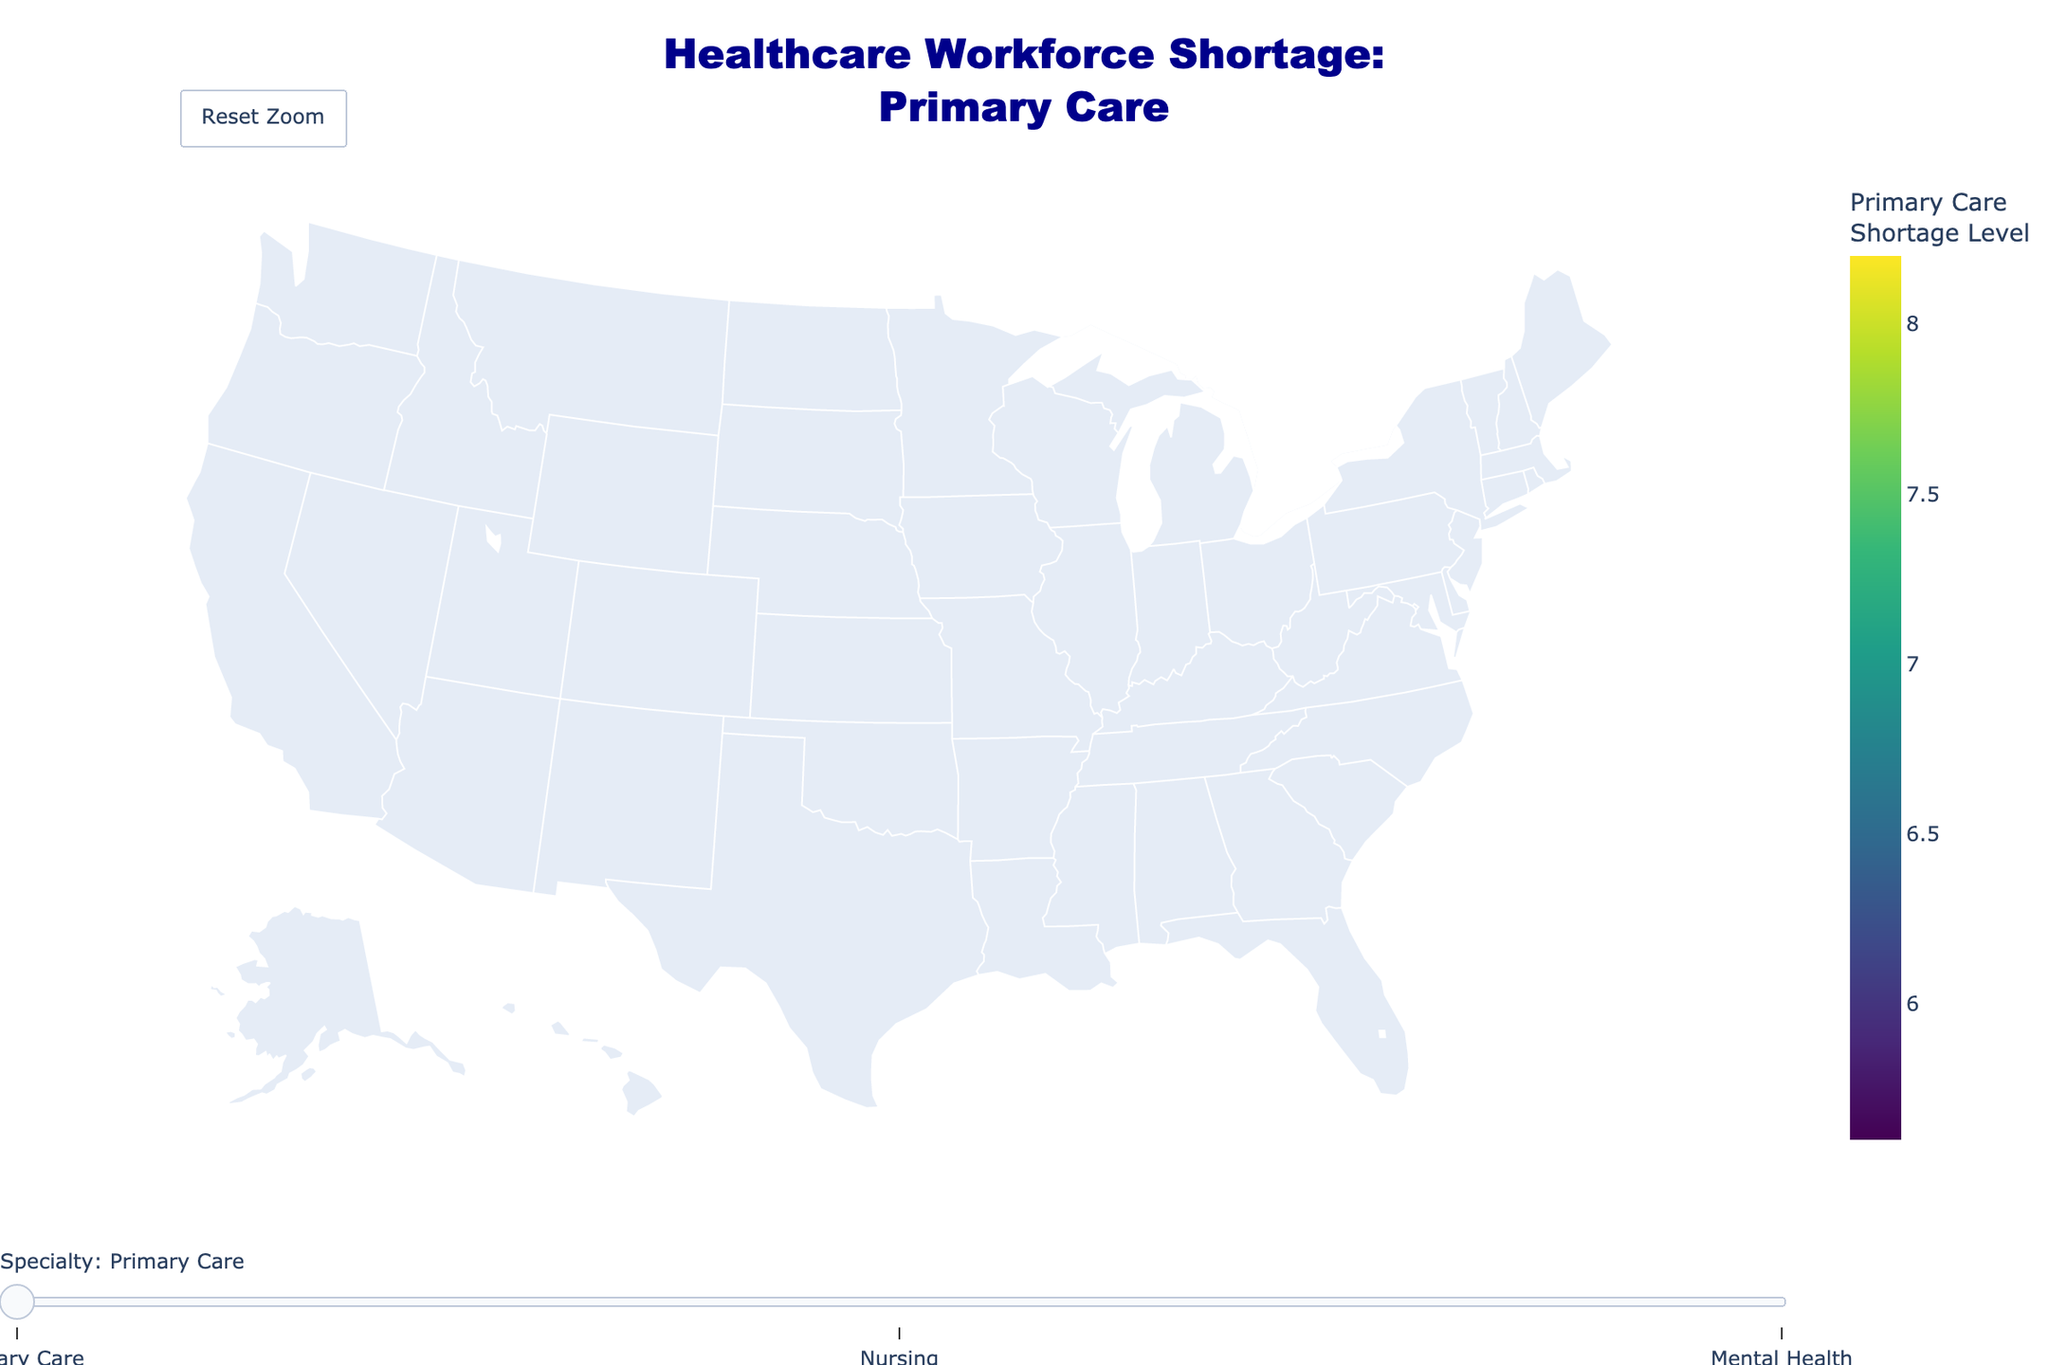Which state shows the highest shortage level in Primary Care? Look at the data associated with Primary Care shortage levels on the map. Identify the state with the highest value.
Answer: California How does the shortage level of Nursing in New York compare to that in California? Identify the shortage levels for the Nursing specialty in New York and California, then compare the two values. New York is 4.7 and California is 6.5, so California's shortage is higher.
Answer: California's shortage is higher What is the average shortage level for Mental Health across all states? Add the Mental Health shortage levels for all states (9.1 + 8.5 + 7.2 + 8.3 + 6.8 + 6.5 + 7.6 + 8.0 + 7.8 + 7.1) and divide by the number of states, which is 10.
Answer: 7.69 Which state has the lowest shortage level in Nursing? Look at the data associated with Nursing shortage levels on the map. Identify the state with the lowest value.
Answer: Pennsylvania Does Ohio have a higher shortage level in Primary Care or in Mental Health? Identify the shortage levels for Primary Care and Mental Health in Ohio, then compare the two values. Ohio's Primary Care is 6.7 and Mental Health is 7.6, so Mental Health is higher.
Answer: Mental Health Is the shortage level of Primary Care in Georgia higher than the shortage level of Nursing in Texas? Compare the shortage levels for Primary Care in Georgia (7.1) and Nursing in Texas (5.9). Georgia's Primary Care is higher.
Answer: Yes What is the range of shortage levels for Nursing across all states? Find the maximum and minimum Nursing shortage levels (California 6.5 and Illinois 4.2, respectively), then calculate the range by subtracting the minimum from the maximum.
Answer: 2.3 Which specialization shows the highest shortage level in Texas? Look at the shortage levels for Primary Care, Nursing, and Mental Health in Texas and identify the highest value.
Answer: Mental Health Are there more states with a shortage level of Primary Care above 7.0 or below 7.0? Count the number of states with Primary Care shortage levels above 7.0 (California, Texas, Florida, Georgia, North Carolina) and below 7.0 (New York, Illinois, Pennsylvania, Ohio, Michigan). Both counts are 5.
Answer: Equal number (5 each) 